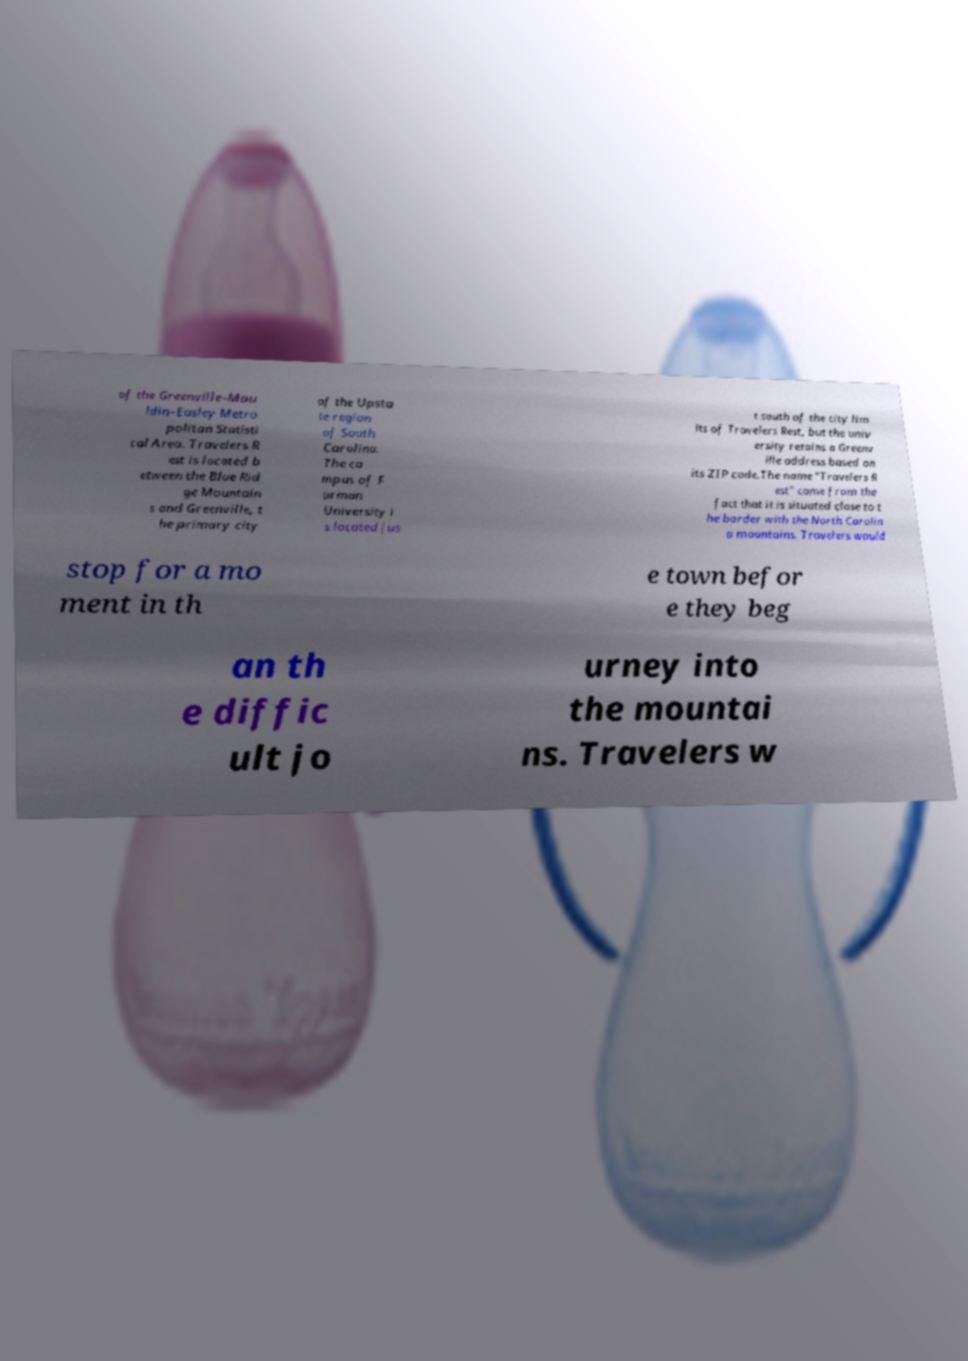Please read and relay the text visible in this image. What does it say? of the Greenville–Mau ldin–Easley Metro politan Statisti cal Area. Travelers R est is located b etween the Blue Rid ge Mountain s and Greenville, t he primary city of the Upsta te region of South Carolina. The ca mpus of F urman University i s located jus t south of the city lim its of Travelers Rest, but the univ ersity retains a Greenv ille address based on its ZIP code.The name "Travelers R est" came from the fact that it is situated close to t he border with the North Carolin a mountains. Travelers would stop for a mo ment in th e town befor e they beg an th e diffic ult jo urney into the mountai ns. Travelers w 